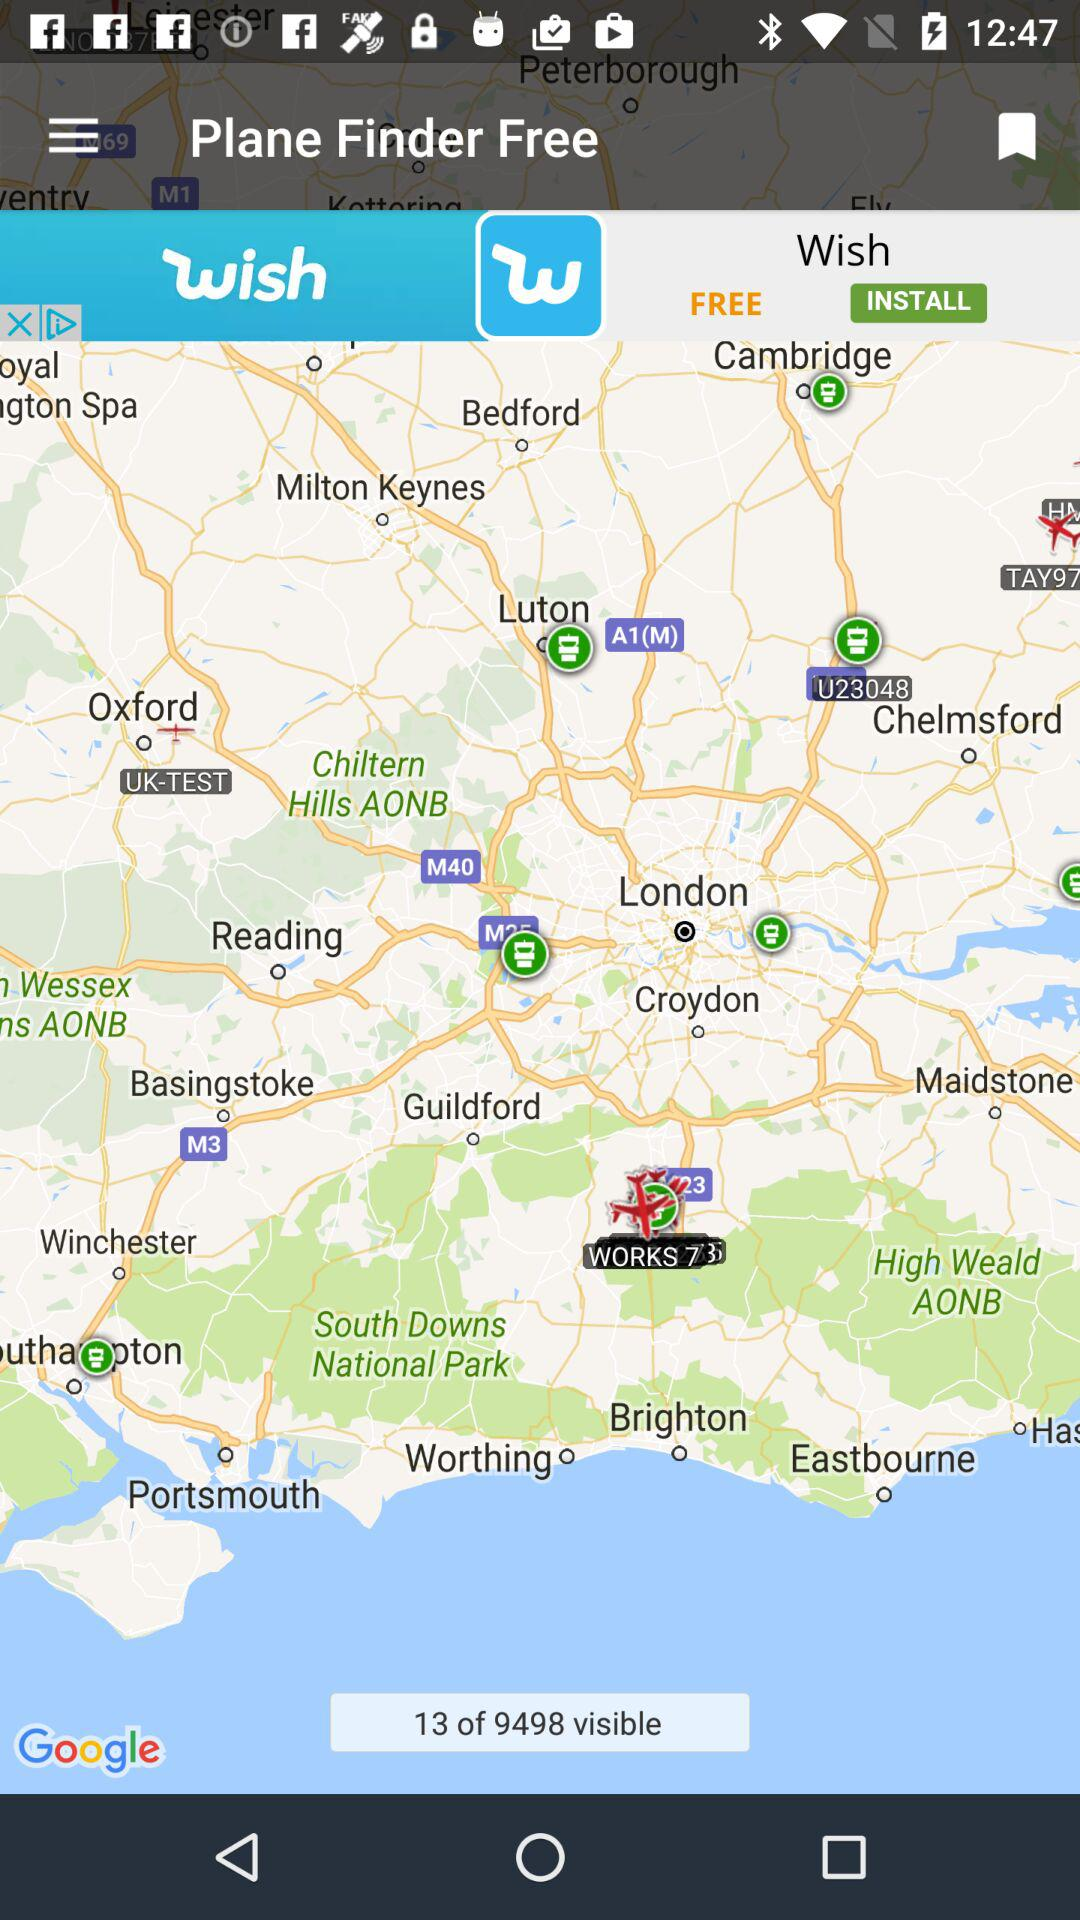How many are visible in total? There are 9498 visible in total. 